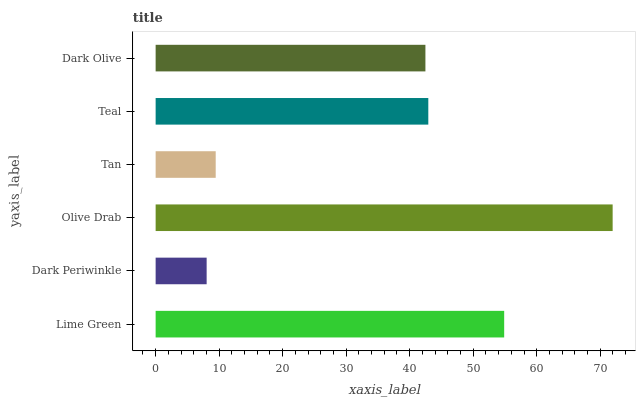Is Dark Periwinkle the minimum?
Answer yes or no. Yes. Is Olive Drab the maximum?
Answer yes or no. Yes. Is Olive Drab the minimum?
Answer yes or no. No. Is Dark Periwinkle the maximum?
Answer yes or no. No. Is Olive Drab greater than Dark Periwinkle?
Answer yes or no. Yes. Is Dark Periwinkle less than Olive Drab?
Answer yes or no. Yes. Is Dark Periwinkle greater than Olive Drab?
Answer yes or no. No. Is Olive Drab less than Dark Periwinkle?
Answer yes or no. No. Is Teal the high median?
Answer yes or no. Yes. Is Dark Olive the low median?
Answer yes or no. Yes. Is Lime Green the high median?
Answer yes or no. No. Is Olive Drab the low median?
Answer yes or no. No. 